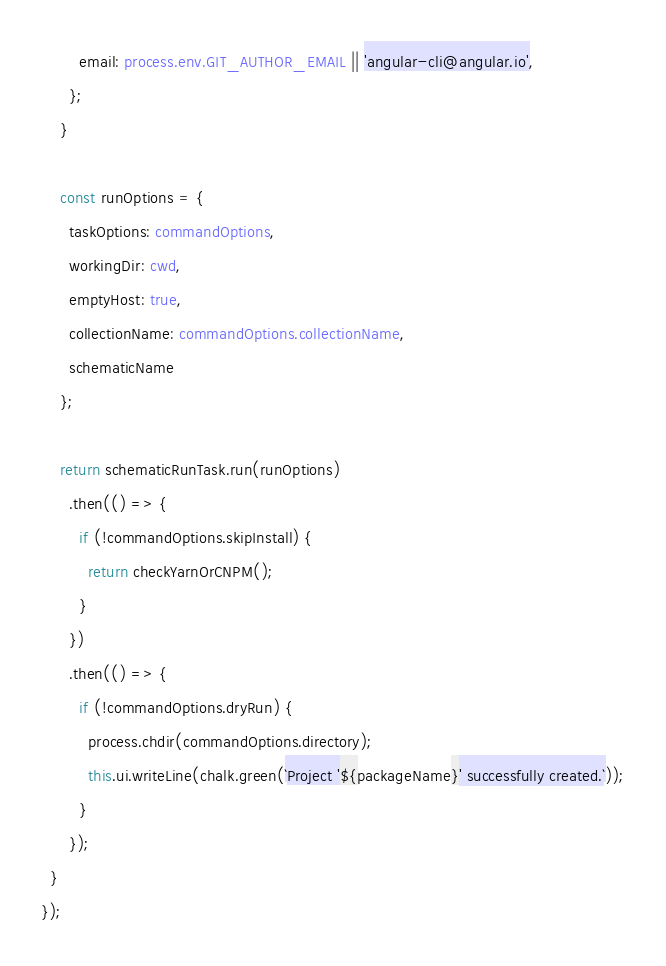Convert code to text. <code><loc_0><loc_0><loc_500><loc_500><_TypeScript_>        email: process.env.GIT_AUTHOR_EMAIL || 'angular-cli@angular.io',
      };
    }

    const runOptions = {
      taskOptions: commandOptions,
      workingDir: cwd,
      emptyHost: true,
      collectionName: commandOptions.collectionName,
      schematicName
    };

    return schematicRunTask.run(runOptions)
      .then(() => {
        if (!commandOptions.skipInstall) {
          return checkYarnOrCNPM();
        }
      })
      .then(() => {
        if (!commandOptions.dryRun) {
          process.chdir(commandOptions.directory);
          this.ui.writeLine(chalk.green(`Project '${packageName}' successfully created.`));
        }
      });
  }
});
</code> 